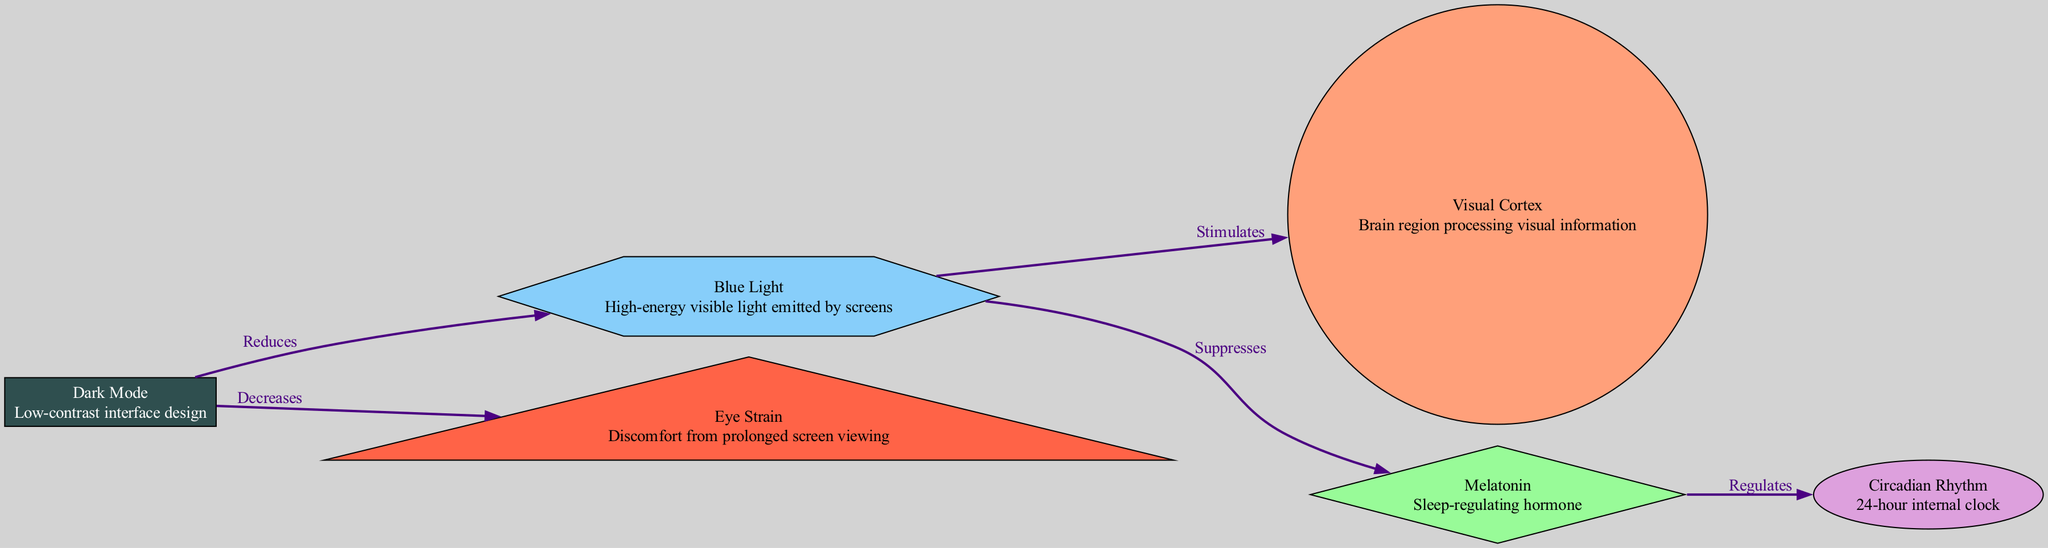What is the role of the visual cortex? The visual cortex is depicted as the brain region processing visual information, and it is a key part of the diagram that illustrates how visual stimuli are interpreted.
Answer: Brain region processing visual information How many nodes are present in the diagram? The diagram contains six nodes: visual cortex, melatonin, blue light, dark mode, circadian rhythm, and eye strain, which are all listed under the nodes section.
Answer: Six What does dark mode reduce? In the diagram, dark mode is shown to reduce blue light exposure, indicated by the edge connecting dark mode and blue light.
Answer: Blue light What hormone is regulated by melatonin? The diagram illustrates that melatonin regulates circadian rhythm, established by the edge connecting melatonin and circadian rhythm.
Answer: Circadian rhythm How does blue light affect melatonin? Blue light suppresses melatonin, as indicated by the directed edge from blue light to melatonin, showing the negative impact of blue light on this hormone.
Answer: Suppresses Which is indicated as decreasing eye strain? The diagram clearly states that dark mode decreases eye strain, as shown by the edge directly connecting dark mode and eye strain.
Answer: Decreases What effect does blue light have on the visual cortex? The diagram states that blue light stimulates the visual cortex, evidenced by the directed edge connecting blue light to visual cortex.
Answer: Stimulates In what way does dark mode relate to eye strain? Dark mode decreases eye strain by reducing the discomfort associated with prolonged screen viewing, as shown by the relationship within the diagram.
Answer: Decreases How does melatonin influence circadian rhythm? The diagram shows a direct relationship where melatonin regulates circadian rhythm, indicating that changes in melatonin levels affect the body's internal clock.
Answer: Regulates 